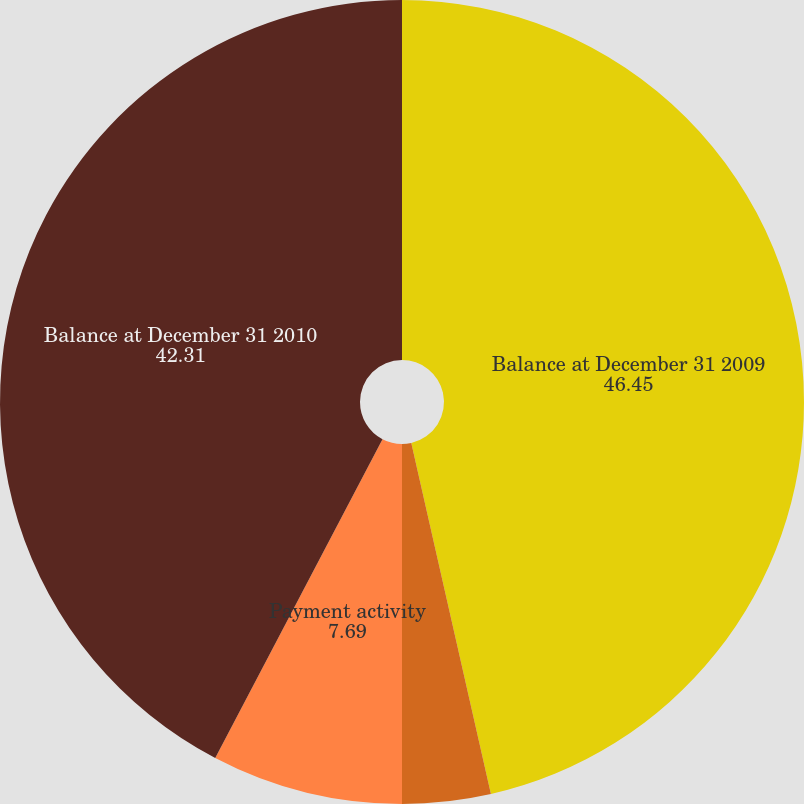Convert chart. <chart><loc_0><loc_0><loc_500><loc_500><pie_chart><fcel>Balance at December 31 2009<fcel>Incurred activity<fcel>Payment activity<fcel>Balance at December 31 2010<nl><fcel>46.45%<fcel>3.55%<fcel>7.69%<fcel>42.31%<nl></chart> 